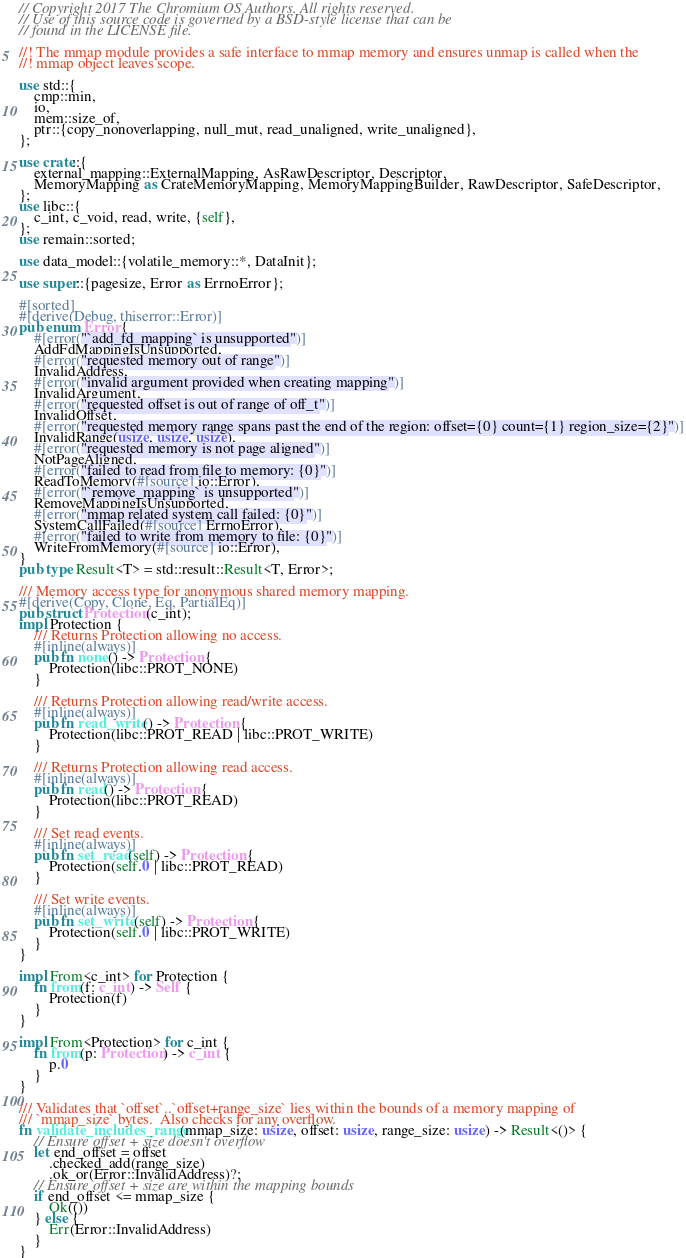Convert code to text. <code><loc_0><loc_0><loc_500><loc_500><_Rust_>// Copyright 2017 The Chromium OS Authors. All rights reserved.
// Use of this source code is governed by a BSD-style license that can be
// found in the LICENSE file.

//! The mmap module provides a safe interface to mmap memory and ensures unmap is called when the
//! mmap object leaves scope.

use std::{
    cmp::min,
    io,
    mem::size_of,
    ptr::{copy_nonoverlapping, null_mut, read_unaligned, write_unaligned},
};

use crate::{
    external_mapping::ExternalMapping, AsRawDescriptor, Descriptor,
    MemoryMapping as CrateMemoryMapping, MemoryMappingBuilder, RawDescriptor, SafeDescriptor,
};
use libc::{
    c_int, c_void, read, write, {self},
};
use remain::sorted;

use data_model::{volatile_memory::*, DataInit};

use super::{pagesize, Error as ErrnoError};

#[sorted]
#[derive(Debug, thiserror::Error)]
pub enum Error {
    #[error("`add_fd_mapping` is unsupported")]
    AddFdMappingIsUnsupported,
    #[error("requested memory out of range")]
    InvalidAddress,
    #[error("invalid argument provided when creating mapping")]
    InvalidArgument,
    #[error("requested offset is out of range of off_t")]
    InvalidOffset,
    #[error("requested memory range spans past the end of the region: offset={0} count={1} region_size={2}")]
    InvalidRange(usize, usize, usize),
    #[error("requested memory is not page aligned")]
    NotPageAligned,
    #[error("failed to read from file to memory: {0}")]
    ReadToMemory(#[source] io::Error),
    #[error("`remove_mapping` is unsupported")]
    RemoveMappingIsUnsupported,
    #[error("mmap related system call failed: {0}")]
    SystemCallFailed(#[source] ErrnoError),
    #[error("failed to write from memory to file: {0}")]
    WriteFromMemory(#[source] io::Error),
}
pub type Result<T> = std::result::Result<T, Error>;

/// Memory access type for anonymous shared memory mapping.
#[derive(Copy, Clone, Eq, PartialEq)]
pub struct Protection(c_int);
impl Protection {
    /// Returns Protection allowing no access.
    #[inline(always)]
    pub fn none() -> Protection {
        Protection(libc::PROT_NONE)
    }

    /// Returns Protection allowing read/write access.
    #[inline(always)]
    pub fn read_write() -> Protection {
        Protection(libc::PROT_READ | libc::PROT_WRITE)
    }

    /// Returns Protection allowing read access.
    #[inline(always)]
    pub fn read() -> Protection {
        Protection(libc::PROT_READ)
    }

    /// Set read events.
    #[inline(always)]
    pub fn set_read(self) -> Protection {
        Protection(self.0 | libc::PROT_READ)
    }

    /// Set write events.
    #[inline(always)]
    pub fn set_write(self) -> Protection {
        Protection(self.0 | libc::PROT_WRITE)
    }
}

impl From<c_int> for Protection {
    fn from(f: c_int) -> Self {
        Protection(f)
    }
}

impl From<Protection> for c_int {
    fn from(p: Protection) -> c_int {
        p.0
    }
}

/// Validates that `offset`..`offset+range_size` lies within the bounds of a memory mapping of
/// `mmap_size` bytes.  Also checks for any overflow.
fn validate_includes_range(mmap_size: usize, offset: usize, range_size: usize) -> Result<()> {
    // Ensure offset + size doesn't overflow
    let end_offset = offset
        .checked_add(range_size)
        .ok_or(Error::InvalidAddress)?;
    // Ensure offset + size are within the mapping bounds
    if end_offset <= mmap_size {
        Ok(())
    } else {
        Err(Error::InvalidAddress)
    }
}
</code> 